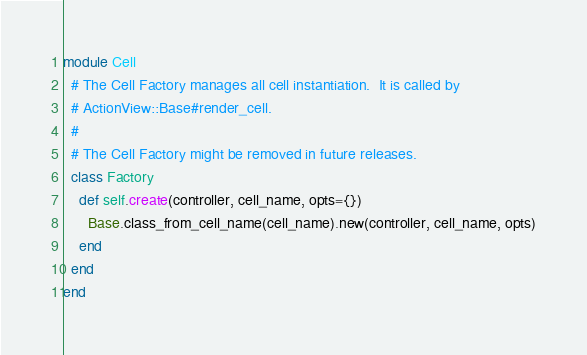Convert code to text. <code><loc_0><loc_0><loc_500><loc_500><_Ruby_>module Cell
  # The Cell Factory manages all cell instantiation.  It is called by
  # ActionView::Base#render_cell.
  #
  # The Cell Factory might be removed in future releases.
  class Factory
    def self.create(controller, cell_name, opts={})
      Base.class_from_cell_name(cell_name).new(controller, cell_name, opts)
    end
  end
end
</code> 